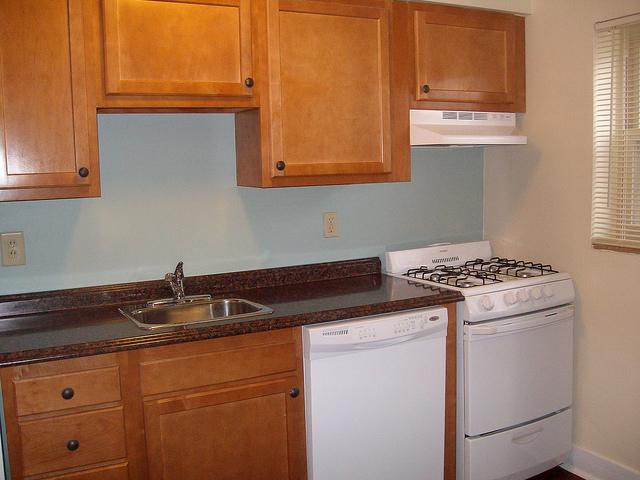How many appliances are shown?
Concise answer only. 2. Is the dishwasher on?
Write a very short answer. No. Can you make coffee in this kitchen?
Quick response, please. No. Is the faucet turned on?
Write a very short answer. No. What color are the cabinets?
Keep it brief. Brown. 